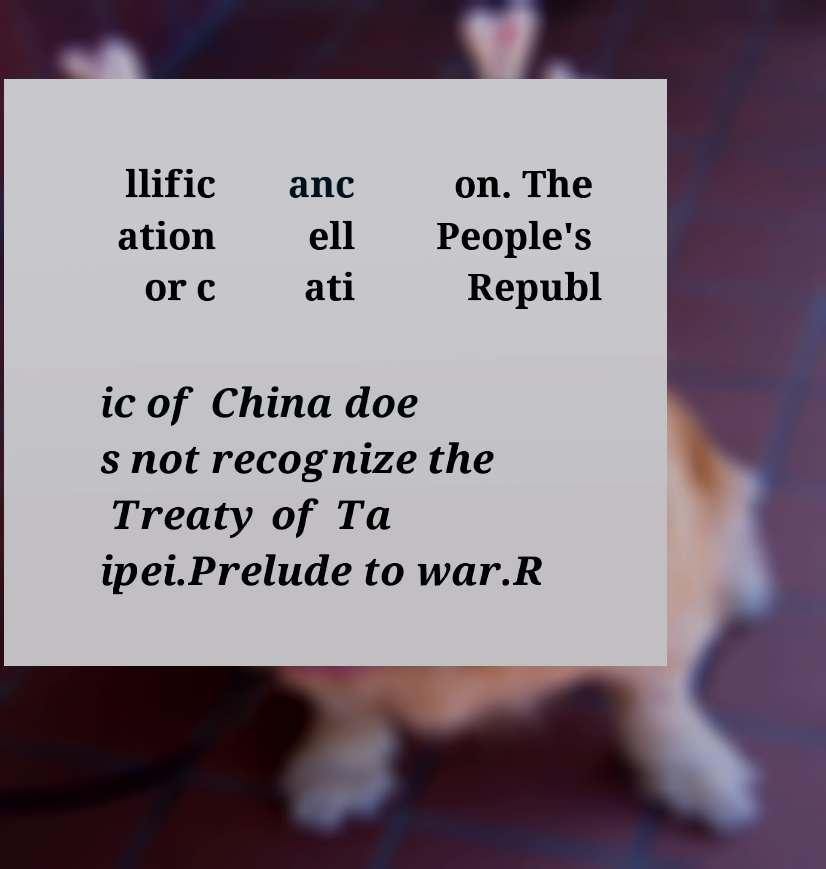Please read and relay the text visible in this image. What does it say? llific ation or c anc ell ati on. The People's Republ ic of China doe s not recognize the Treaty of Ta ipei.Prelude to war.R 